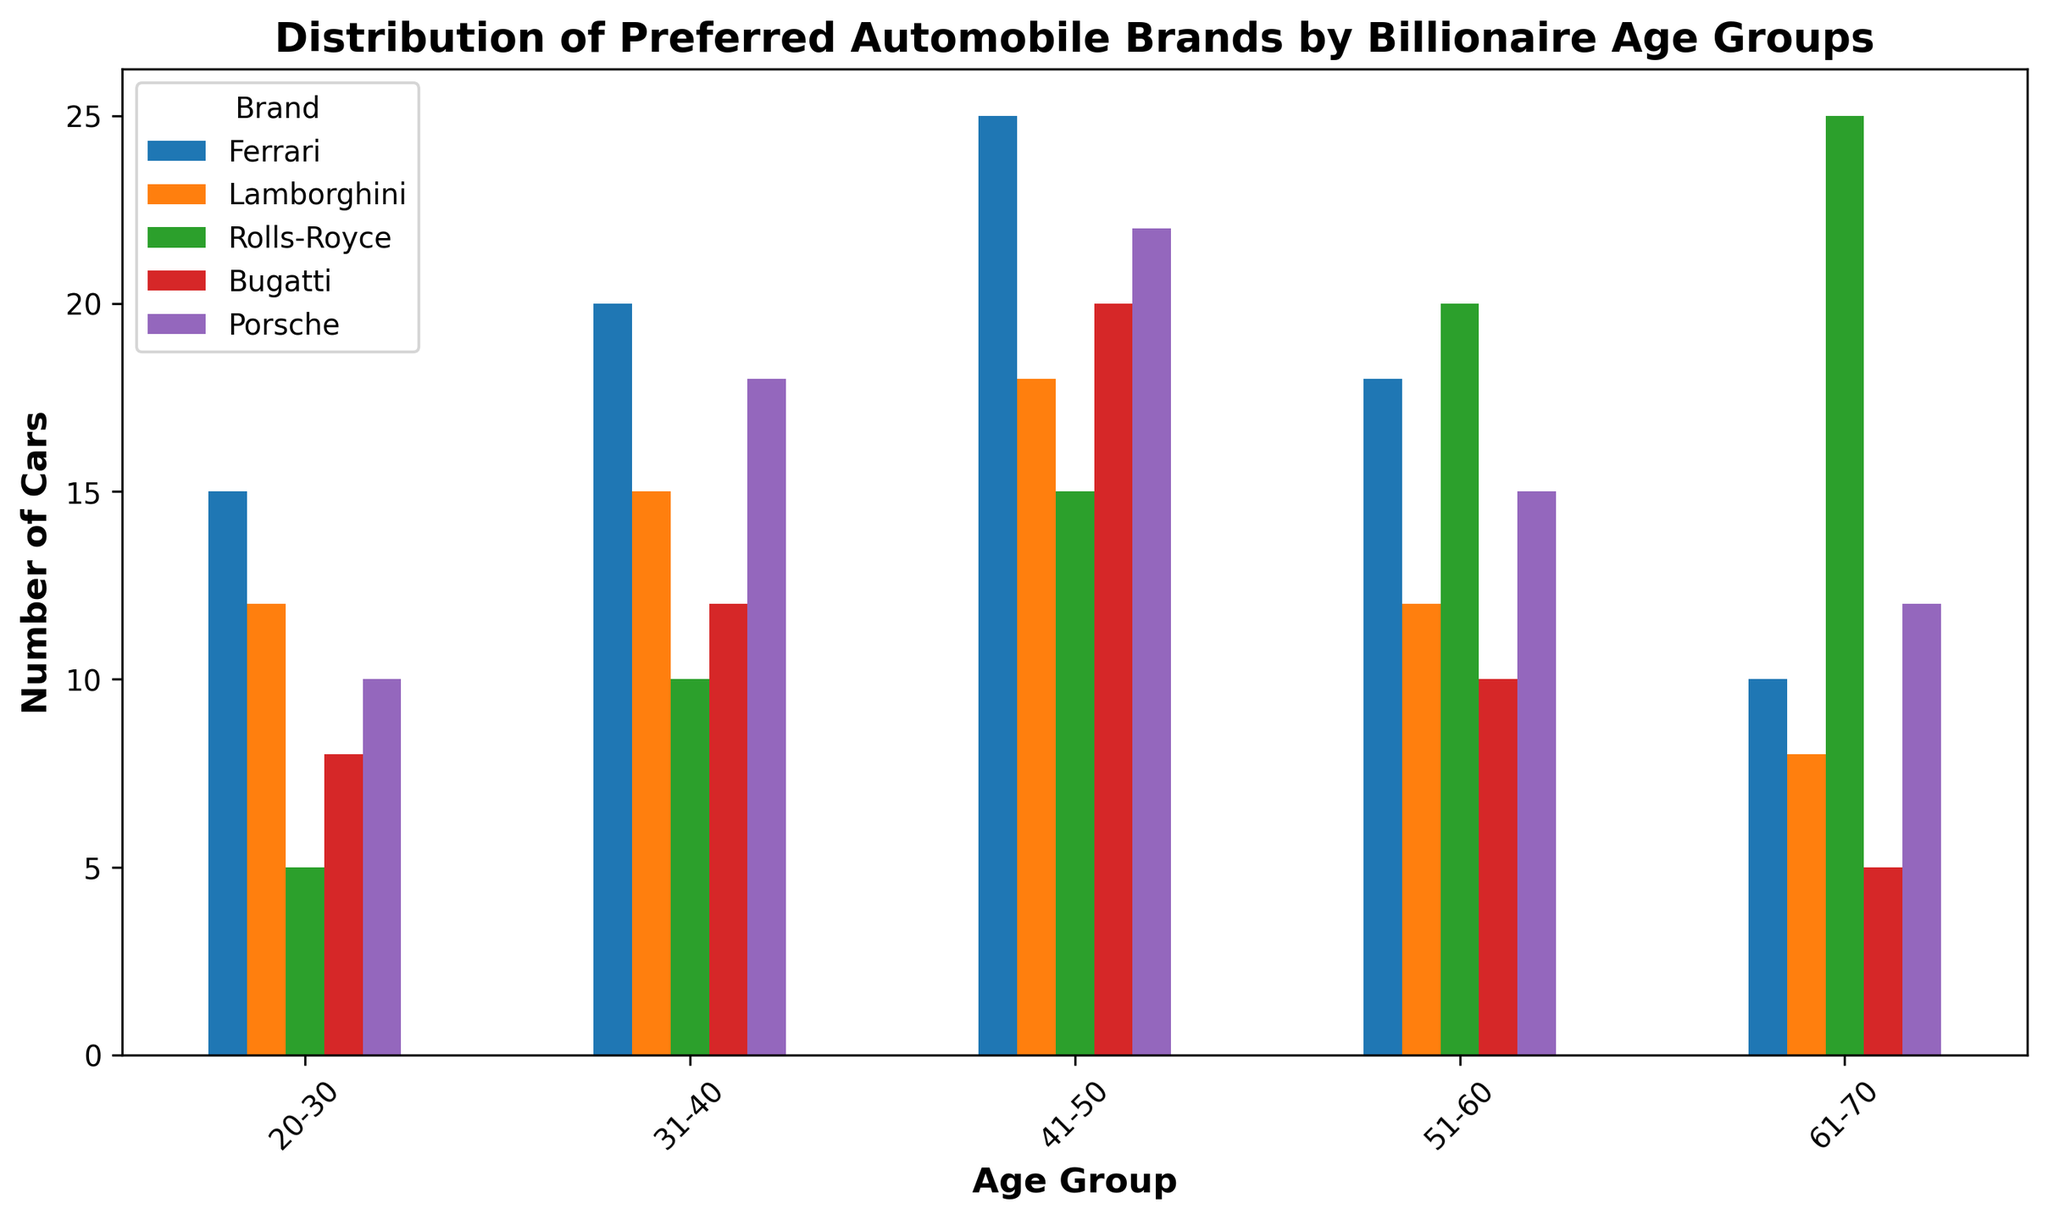Which age group shows the highest preference for Rolls-Royce? To determine this, we look for the tallest bar labeled "Rolls-Royce" among the age groups. The bar for age group 61-70 is the tallest among Rolls-Royce bars.
Answer: 61-70 How many more Ferraris do billionaires aged 41-50 prefer compared to those aged 20-30? Compare the heights of the bars labeled "Ferrari" for age groups 41-50 and 20-30. The value for 41-50 is 25, and for 20-30, it's 15. The difference is 25 - 15.
Answer: 10 Which two brands are least preferred by the 61-70 age group? Look at the bars for the 61-70 age group and find the shortest bars. The shortest bars are for Bugatti and Lamborghini, both with values of 5 and 8 respectively.
Answer: Bugatti and Lamborghini What is the total number of Lamborghinis preferred by billionaires? Sum up the values of the bars labeled "Lamborghini" across all age groups: 12 (20-30) + 15 (31-40) + 18 (41-50) + 12 (51-60) + 8 (61-70) = 65.
Answer: 65 Which brand sees the largest increase in preference from age group 20-30 to 31-40? Determine the difference in bar heights between age groups 20-30 and 31-40 for each brand. The largest difference is for Ferrari (20 - 15 = 5).
Answer: Ferrari Among the age groups, which one has the second highest preference for Bugatti? Compare the heights of the bars labeled "Bugatti" for each age group. The second tallest bar, after 41-50 (20), is for 31-40 (12).
Answer: 31-40 What is the average number of Porsches preferred by all age groups? Compute the sum of Porsches preferred by each age group and divide by the number of age groups: (10+18+22+15+12)/5 = 77/5 = 15.4.
Answer: 15.4 Is the preference for Ferrari generally increasing or decreasing with age? Observe the height of the bars labeled "Ferrari" across age groups: 15 (20-30), 20 (31-40), 25 (41-50), 18 (51-60), 10 (61-70). The general trend is initially increasing and then decreasing.
Answer: Initially increasing, then decreasing Which brand has the most uniform distribution of preferences across the age groups? Compare the range (difference between maximum and minimum values) for each brand. The most uniform distribution will have the smallest range. For Porsche: 22 - 10 = 12, for Lamborghini: 18 - 8 = 10, etc. Rolls-Royce has the smallest range: 25 - 5 = 20.
Answer: Porsche 